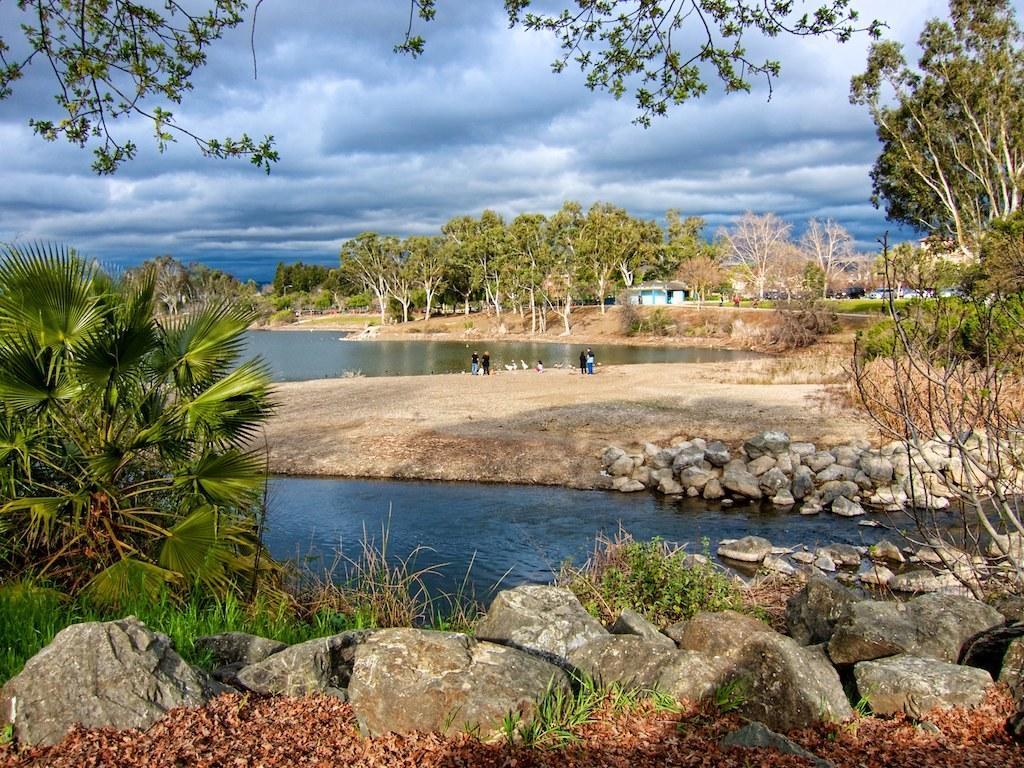Can you describe this image briefly? In this picture we can see stones, plants, trees, vehicles, houses, water and some people on the ground and some objects and in the background we can see the sky with clouds. 